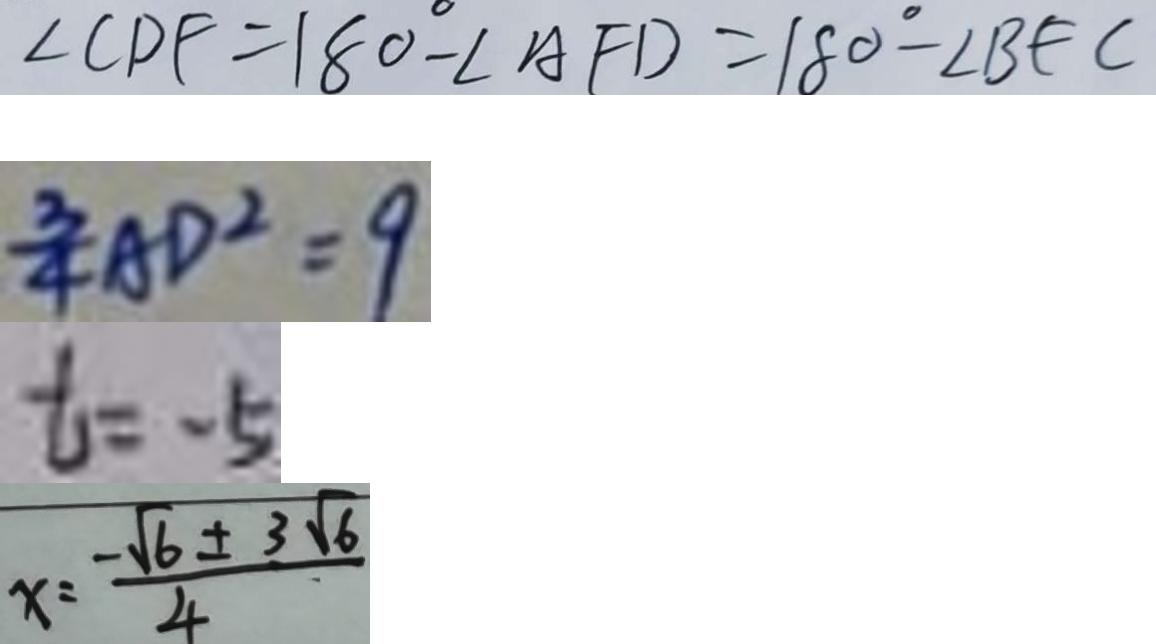Convert formula to latex. <formula><loc_0><loc_0><loc_500><loc_500>\angle C D F = 1 8 0 ^ { \circ } - \angle A F D = 1 8 0 ^ { \circ } - \angle B F C 
 \frac { 3 } { 4 } A D ^ { 2 } = 9 
 t = - 5 
 x = \frac { - \sqrt { 6 } \pm 3 \sqrt { 6 } } { 4 }</formula> 